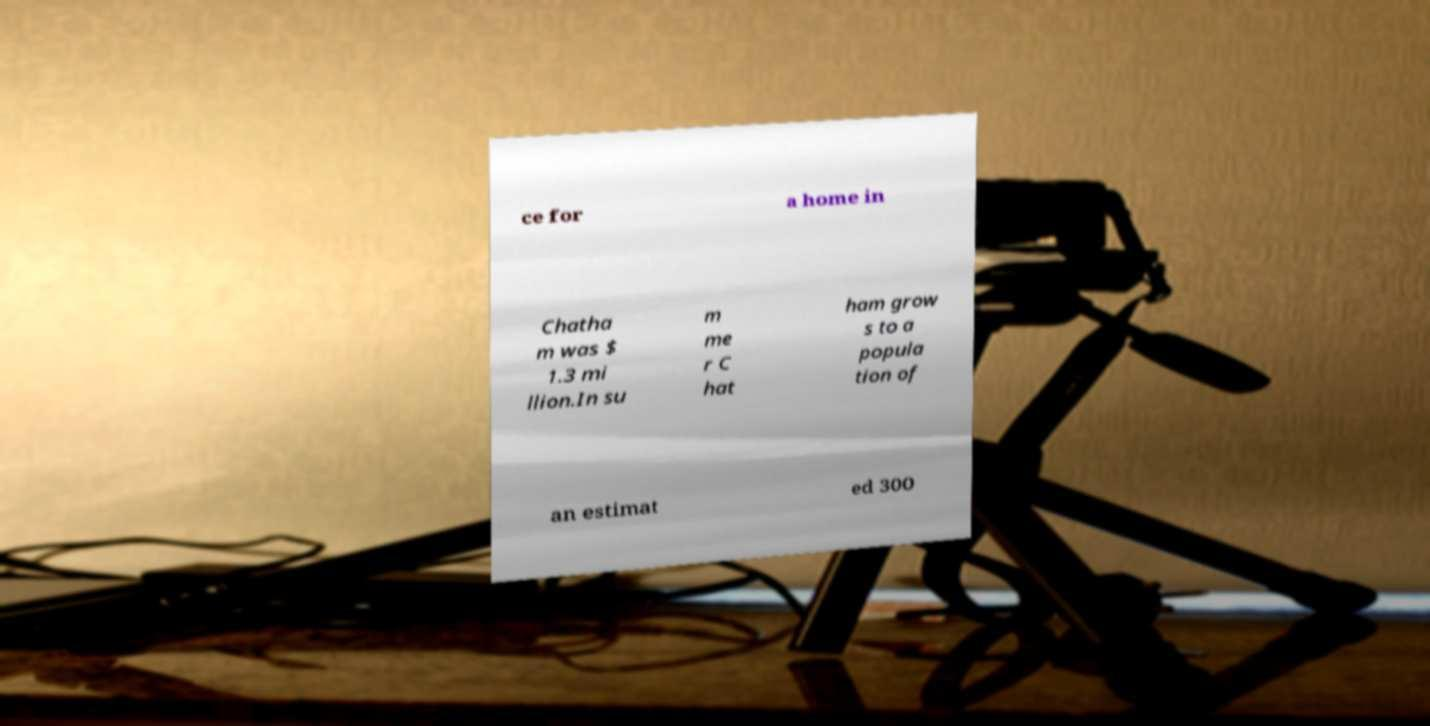Could you extract and type out the text from this image? ce for a home in Chatha m was $ 1.3 mi llion.In su m me r C hat ham grow s to a popula tion of an estimat ed 300 